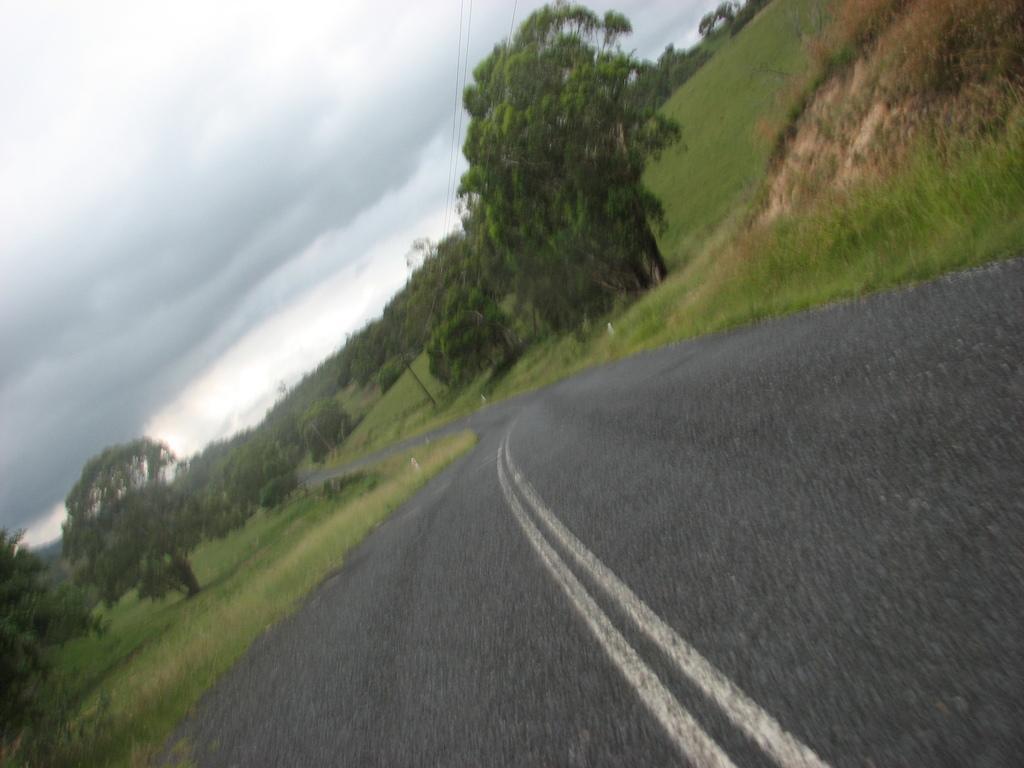In one or two sentences, can you explain what this image depicts? In this picture we can see the sky, road, grass and trees. 